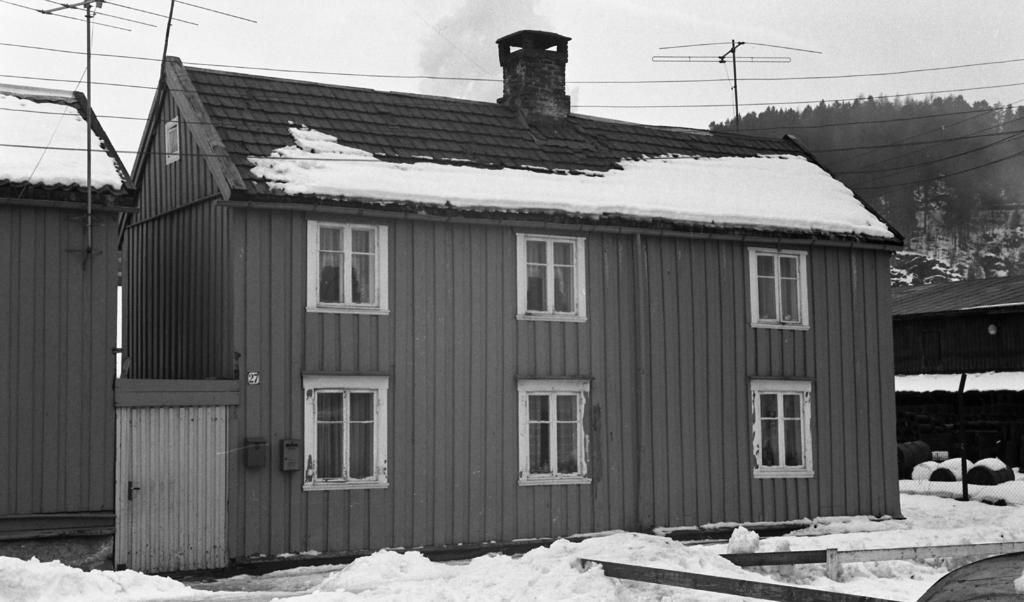Could you give a brief overview of what you see in this image? In this image we can see house, snow, trees and electric wires. 